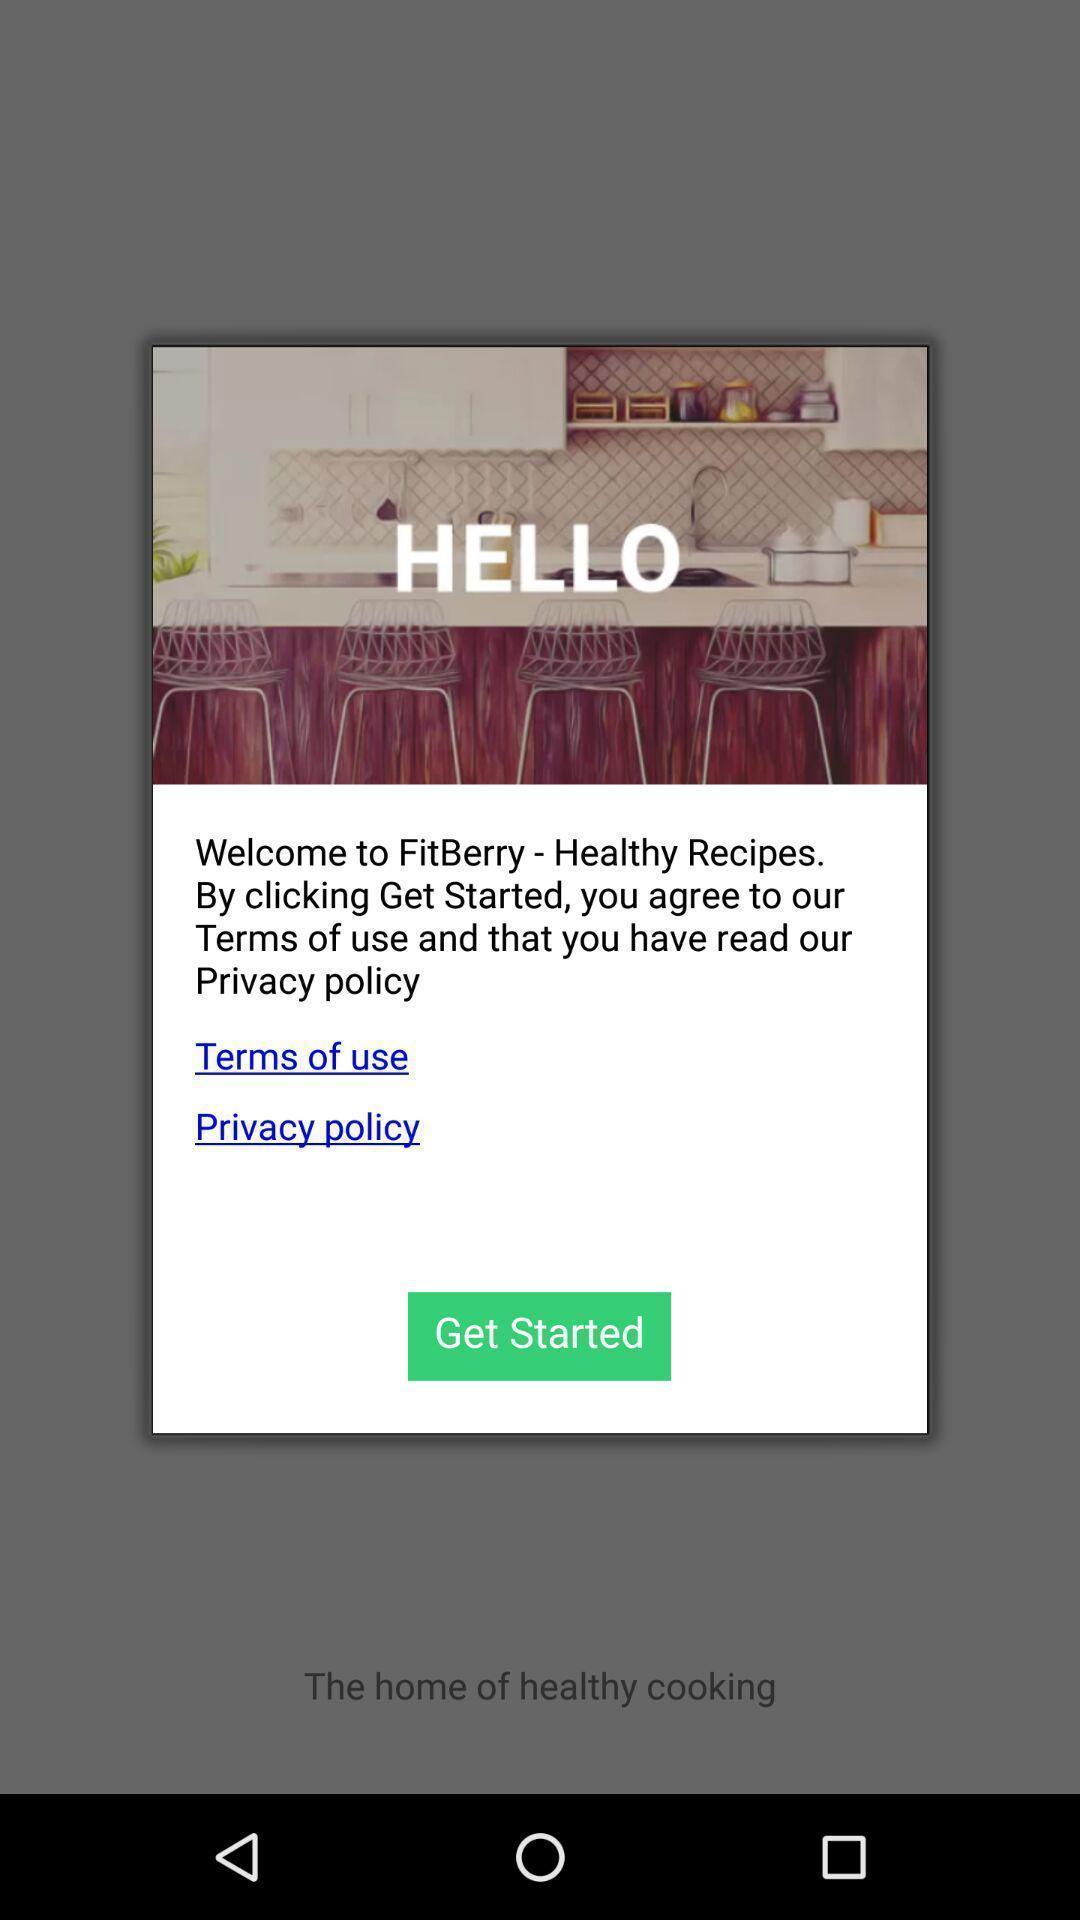Describe the content in this image. Pop-up displaying welcome message for healthy recipes app. 